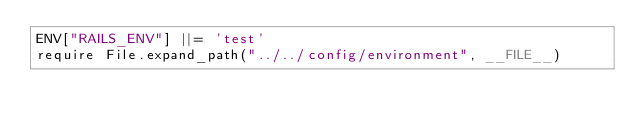<code> <loc_0><loc_0><loc_500><loc_500><_Ruby_>ENV["RAILS_ENV"] ||= 'test'
require File.expand_path("../../config/environment", __FILE__)
</code> 